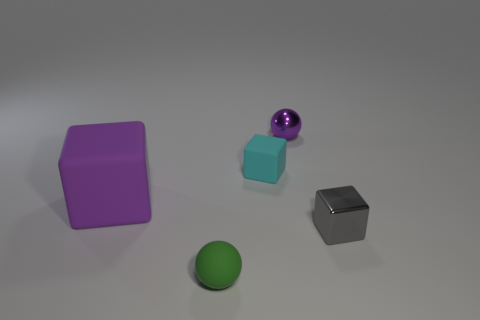Subtract all green blocks. Subtract all gray balls. How many blocks are left? 3 Add 3 small green things. How many objects exist? 8 Subtract all cubes. How many objects are left? 2 Add 3 large blue matte things. How many large blue matte things exist? 3 Subtract 0 red blocks. How many objects are left? 5 Subtract all tiny cyan matte things. Subtract all tiny metal cubes. How many objects are left? 3 Add 3 tiny gray metal cubes. How many tiny gray metal cubes are left? 4 